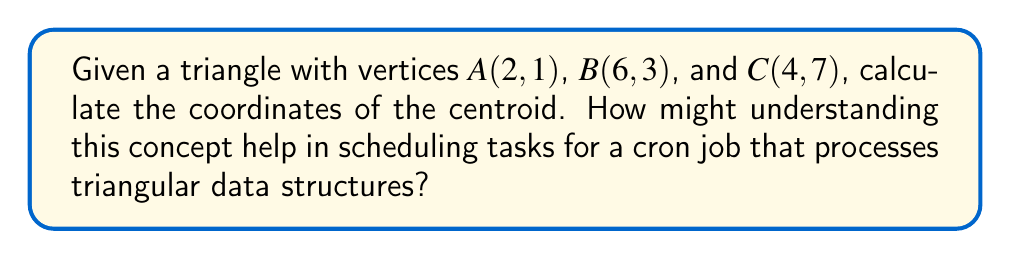Provide a solution to this math problem. To find the centroid of a triangle, we need to follow these steps:

1. Recall that the centroid of a triangle is located at the intersection of its medians, and its coordinates are the arithmetic mean of the coordinates of the three vertices.

2. Let's denote the centroid as G(x, y). We can calculate its coordinates using these formulas:

   $$x = \frac{x_A + x_B + x_C}{3}$$
   $$y = \frac{y_A + y_B + y_C}{3}$$

   Where $(x_A, y_A)$, $(x_B, y_B)$, and $(x_C, y_C)$ are the coordinates of vertices A, B, and C respectively.

3. Substitute the given coordinates:
   $$x = \frac{2 + 6 + 4}{3} = \frac{12}{3} = 4$$
   $$y = \frac{1 + 3 + 7}{3} = \frac{11}{3}$$

4. Therefore, the centroid G has coordinates (4, 11/3).

Understanding this concept can help in scheduling cron jobs that process triangular data structures by allowing efficient calculation of central points. This could be useful for load balancing or distributing tasks evenly across a triangle-based data model.

[asy]
unitsize(1cm);
pair A = (2,1), B = (6,3), C = (4,7), G = (4,11/3);
draw(A--B--C--cycle);
dot("A", A, SW);
dot("B", B, SE);
dot("C", C, N);
dot("G", G, E);
[/asy]
Answer: G(4, 11/3) 